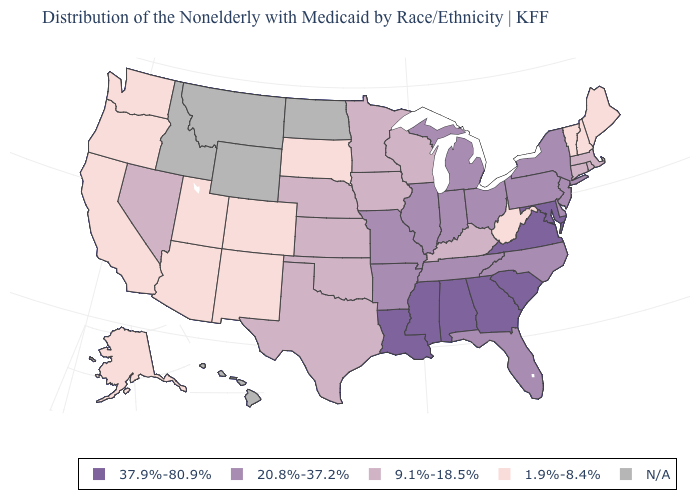Does Oregon have the lowest value in the West?
Be succinct. Yes. Name the states that have a value in the range 1.9%-8.4%?
Give a very brief answer. Alaska, Arizona, California, Colorado, Maine, New Hampshire, New Mexico, Oregon, South Dakota, Utah, Vermont, Washington, West Virginia. Does the first symbol in the legend represent the smallest category?
Concise answer only. No. Name the states that have a value in the range 20.8%-37.2%?
Short answer required. Arkansas, Delaware, Florida, Illinois, Indiana, Michigan, Missouri, New Jersey, New York, North Carolina, Ohio, Pennsylvania, Tennessee. What is the lowest value in states that border Utah?
Short answer required. 1.9%-8.4%. What is the value of New Mexico?
Be succinct. 1.9%-8.4%. Does the map have missing data?
Be succinct. Yes. Which states have the highest value in the USA?
Give a very brief answer. Alabama, Georgia, Louisiana, Maryland, Mississippi, South Carolina, Virginia. What is the value of New Jersey?
Write a very short answer. 20.8%-37.2%. Does Nebraska have the highest value in the USA?
Concise answer only. No. Which states have the highest value in the USA?
Answer briefly. Alabama, Georgia, Louisiana, Maryland, Mississippi, South Carolina, Virginia. Name the states that have a value in the range 1.9%-8.4%?
Concise answer only. Alaska, Arizona, California, Colorado, Maine, New Hampshire, New Mexico, Oregon, South Dakota, Utah, Vermont, Washington, West Virginia. Which states have the lowest value in the USA?
Give a very brief answer. Alaska, Arizona, California, Colorado, Maine, New Hampshire, New Mexico, Oregon, South Dakota, Utah, Vermont, Washington, West Virginia. 